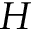<formula> <loc_0><loc_0><loc_500><loc_500>H</formula> 